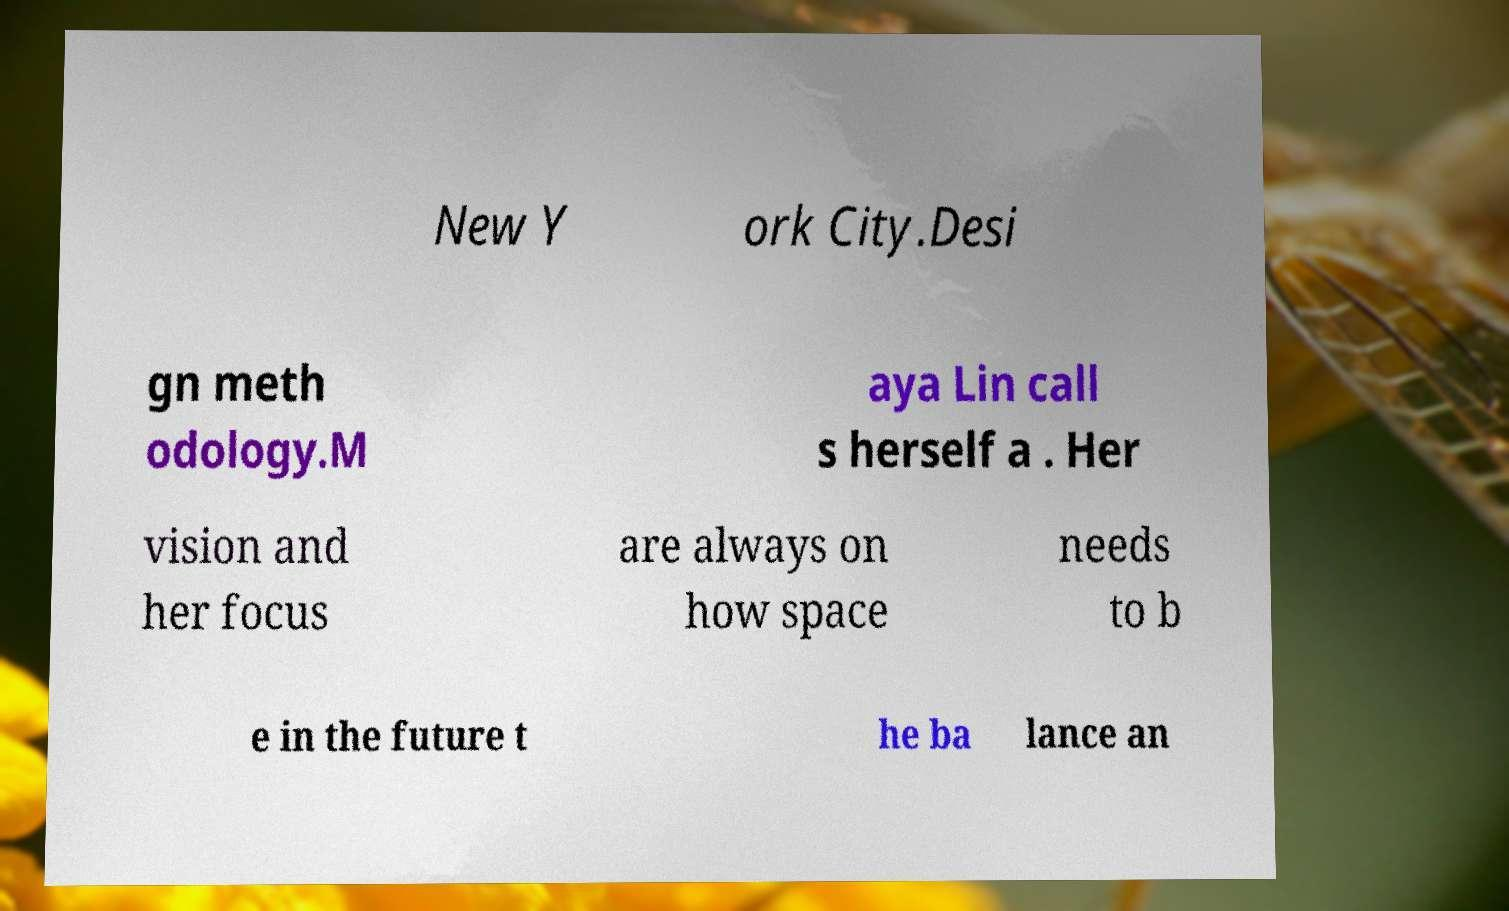Please identify and transcribe the text found in this image. New Y ork City.Desi gn meth odology.M aya Lin call s herself a . Her vision and her focus are always on how space needs to b e in the future t he ba lance an 